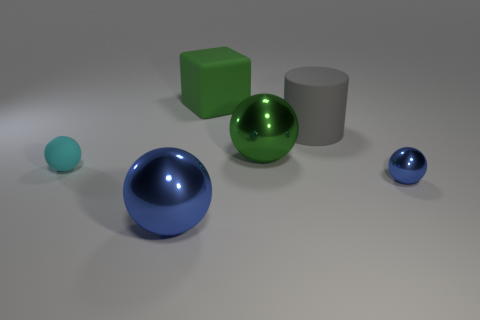Subtract 1 balls. How many balls are left? 3 Add 2 small rubber things. How many objects exist? 8 Subtract all blocks. How many objects are left? 5 Subtract all yellow rubber things. Subtract all big gray matte objects. How many objects are left? 5 Add 2 metallic things. How many metallic things are left? 5 Add 1 big purple rubber cylinders. How many big purple rubber cylinders exist? 1 Subtract 0 yellow spheres. How many objects are left? 6 